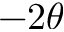Convert formula to latex. <formula><loc_0><loc_0><loc_500><loc_500>- 2 \theta</formula> 